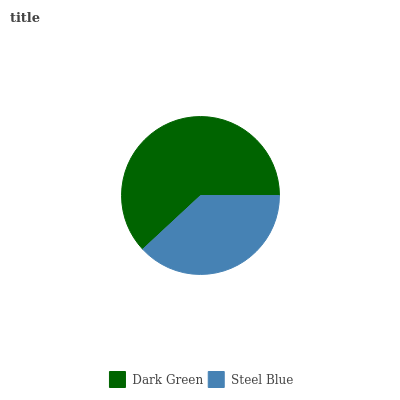Is Steel Blue the minimum?
Answer yes or no. Yes. Is Dark Green the maximum?
Answer yes or no. Yes. Is Steel Blue the maximum?
Answer yes or no. No. Is Dark Green greater than Steel Blue?
Answer yes or no. Yes. Is Steel Blue less than Dark Green?
Answer yes or no. Yes. Is Steel Blue greater than Dark Green?
Answer yes or no. No. Is Dark Green less than Steel Blue?
Answer yes or no. No. Is Dark Green the high median?
Answer yes or no. Yes. Is Steel Blue the low median?
Answer yes or no. Yes. Is Steel Blue the high median?
Answer yes or no. No. Is Dark Green the low median?
Answer yes or no. No. 